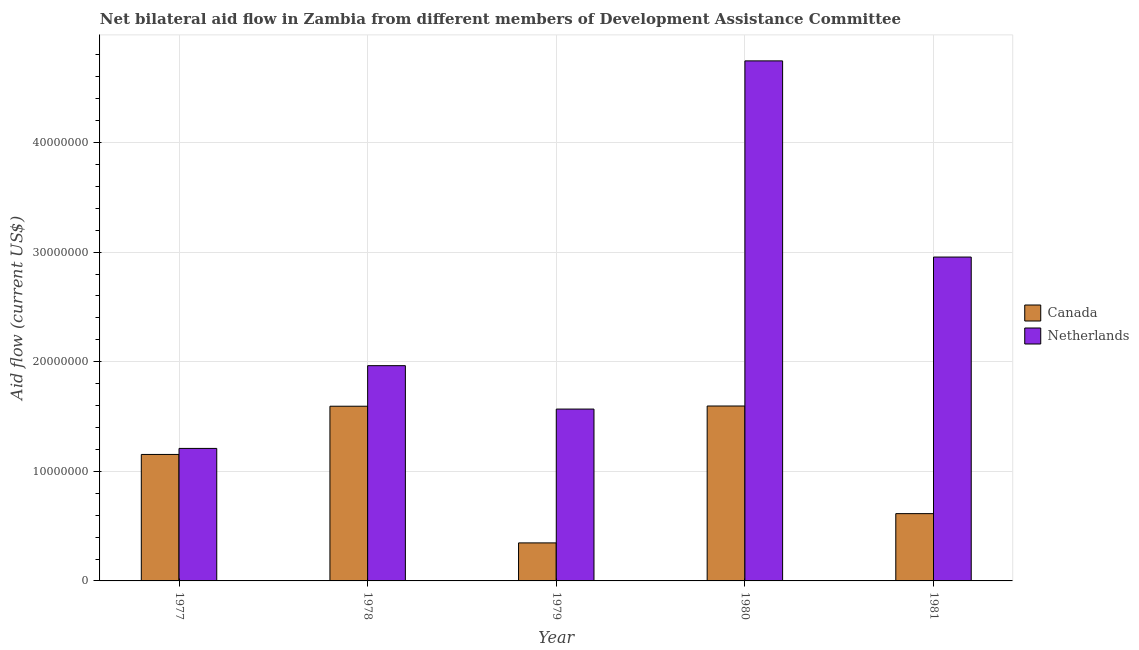How many different coloured bars are there?
Make the answer very short. 2. Are the number of bars per tick equal to the number of legend labels?
Provide a short and direct response. Yes. Are the number of bars on each tick of the X-axis equal?
Provide a succinct answer. Yes. What is the label of the 5th group of bars from the left?
Offer a very short reply. 1981. What is the amount of aid given by netherlands in 1981?
Ensure brevity in your answer.  2.96e+07. Across all years, what is the maximum amount of aid given by canada?
Give a very brief answer. 1.60e+07. Across all years, what is the minimum amount of aid given by netherlands?
Your response must be concise. 1.21e+07. In which year was the amount of aid given by canada minimum?
Provide a short and direct response. 1979. What is the total amount of aid given by canada in the graph?
Provide a short and direct response. 5.30e+07. What is the difference between the amount of aid given by canada in 1979 and that in 1980?
Give a very brief answer. -1.25e+07. What is the difference between the amount of aid given by netherlands in 1979 and the amount of aid given by canada in 1977?
Provide a short and direct response. 3.59e+06. What is the average amount of aid given by canada per year?
Your response must be concise. 1.06e+07. In how many years, is the amount of aid given by canada greater than 6000000 US$?
Your response must be concise. 4. What is the ratio of the amount of aid given by canada in 1980 to that in 1981?
Offer a terse response. 2.6. Is the amount of aid given by netherlands in 1980 less than that in 1981?
Offer a terse response. No. Is the difference between the amount of aid given by netherlands in 1978 and 1980 greater than the difference between the amount of aid given by canada in 1978 and 1980?
Your answer should be very brief. No. What is the difference between the highest and the lowest amount of aid given by canada?
Offer a terse response. 1.25e+07. What does the 1st bar from the left in 1981 represents?
Provide a succinct answer. Canada. How many bars are there?
Your answer should be very brief. 10. Are all the bars in the graph horizontal?
Provide a succinct answer. No. How many years are there in the graph?
Ensure brevity in your answer.  5. Does the graph contain any zero values?
Your answer should be compact. No. How many legend labels are there?
Offer a very short reply. 2. How are the legend labels stacked?
Your answer should be compact. Vertical. What is the title of the graph?
Make the answer very short. Net bilateral aid flow in Zambia from different members of Development Assistance Committee. Does "Lower secondary rate" appear as one of the legend labels in the graph?
Provide a succinct answer. No. What is the label or title of the X-axis?
Your response must be concise. Year. What is the Aid flow (current US$) in Canada in 1977?
Provide a succinct answer. 1.15e+07. What is the Aid flow (current US$) in Netherlands in 1977?
Keep it short and to the point. 1.21e+07. What is the Aid flow (current US$) in Canada in 1978?
Ensure brevity in your answer.  1.59e+07. What is the Aid flow (current US$) of Netherlands in 1978?
Your response must be concise. 1.96e+07. What is the Aid flow (current US$) in Canada in 1979?
Provide a succinct answer. 3.47e+06. What is the Aid flow (current US$) in Netherlands in 1979?
Offer a terse response. 1.57e+07. What is the Aid flow (current US$) in Canada in 1980?
Your answer should be very brief. 1.60e+07. What is the Aid flow (current US$) of Netherlands in 1980?
Your response must be concise. 4.74e+07. What is the Aid flow (current US$) of Canada in 1981?
Offer a terse response. 6.14e+06. What is the Aid flow (current US$) in Netherlands in 1981?
Make the answer very short. 2.96e+07. Across all years, what is the maximum Aid flow (current US$) in Canada?
Your answer should be very brief. 1.60e+07. Across all years, what is the maximum Aid flow (current US$) in Netherlands?
Your response must be concise. 4.74e+07. Across all years, what is the minimum Aid flow (current US$) in Canada?
Provide a short and direct response. 3.47e+06. Across all years, what is the minimum Aid flow (current US$) of Netherlands?
Provide a short and direct response. 1.21e+07. What is the total Aid flow (current US$) in Canada in the graph?
Provide a succinct answer. 5.30e+07. What is the total Aid flow (current US$) in Netherlands in the graph?
Keep it short and to the point. 1.24e+08. What is the difference between the Aid flow (current US$) of Canada in 1977 and that in 1978?
Your response must be concise. -4.40e+06. What is the difference between the Aid flow (current US$) of Netherlands in 1977 and that in 1978?
Provide a short and direct response. -7.55e+06. What is the difference between the Aid flow (current US$) of Canada in 1977 and that in 1979?
Your response must be concise. 8.07e+06. What is the difference between the Aid flow (current US$) in Netherlands in 1977 and that in 1979?
Keep it short and to the point. -3.59e+06. What is the difference between the Aid flow (current US$) of Canada in 1977 and that in 1980?
Keep it short and to the point. -4.42e+06. What is the difference between the Aid flow (current US$) of Netherlands in 1977 and that in 1980?
Your answer should be compact. -3.54e+07. What is the difference between the Aid flow (current US$) in Canada in 1977 and that in 1981?
Offer a very short reply. 5.40e+06. What is the difference between the Aid flow (current US$) of Netherlands in 1977 and that in 1981?
Give a very brief answer. -1.75e+07. What is the difference between the Aid flow (current US$) of Canada in 1978 and that in 1979?
Your answer should be very brief. 1.25e+07. What is the difference between the Aid flow (current US$) in Netherlands in 1978 and that in 1979?
Keep it short and to the point. 3.96e+06. What is the difference between the Aid flow (current US$) in Canada in 1978 and that in 1980?
Keep it short and to the point. -2.00e+04. What is the difference between the Aid flow (current US$) of Netherlands in 1978 and that in 1980?
Your answer should be very brief. -2.78e+07. What is the difference between the Aid flow (current US$) of Canada in 1978 and that in 1981?
Your answer should be very brief. 9.80e+06. What is the difference between the Aid flow (current US$) of Netherlands in 1978 and that in 1981?
Your response must be concise. -9.91e+06. What is the difference between the Aid flow (current US$) in Canada in 1979 and that in 1980?
Offer a terse response. -1.25e+07. What is the difference between the Aid flow (current US$) in Netherlands in 1979 and that in 1980?
Ensure brevity in your answer.  -3.18e+07. What is the difference between the Aid flow (current US$) in Canada in 1979 and that in 1981?
Keep it short and to the point. -2.67e+06. What is the difference between the Aid flow (current US$) in Netherlands in 1979 and that in 1981?
Give a very brief answer. -1.39e+07. What is the difference between the Aid flow (current US$) in Canada in 1980 and that in 1981?
Provide a succinct answer. 9.82e+06. What is the difference between the Aid flow (current US$) of Netherlands in 1980 and that in 1981?
Give a very brief answer. 1.79e+07. What is the difference between the Aid flow (current US$) in Canada in 1977 and the Aid flow (current US$) in Netherlands in 1978?
Provide a short and direct response. -8.10e+06. What is the difference between the Aid flow (current US$) in Canada in 1977 and the Aid flow (current US$) in Netherlands in 1979?
Keep it short and to the point. -4.14e+06. What is the difference between the Aid flow (current US$) in Canada in 1977 and the Aid flow (current US$) in Netherlands in 1980?
Offer a terse response. -3.59e+07. What is the difference between the Aid flow (current US$) of Canada in 1977 and the Aid flow (current US$) of Netherlands in 1981?
Offer a very short reply. -1.80e+07. What is the difference between the Aid flow (current US$) in Canada in 1978 and the Aid flow (current US$) in Netherlands in 1979?
Make the answer very short. 2.60e+05. What is the difference between the Aid flow (current US$) of Canada in 1978 and the Aid flow (current US$) of Netherlands in 1980?
Your answer should be compact. -3.15e+07. What is the difference between the Aid flow (current US$) of Canada in 1978 and the Aid flow (current US$) of Netherlands in 1981?
Offer a very short reply. -1.36e+07. What is the difference between the Aid flow (current US$) of Canada in 1979 and the Aid flow (current US$) of Netherlands in 1980?
Offer a terse response. -4.40e+07. What is the difference between the Aid flow (current US$) of Canada in 1979 and the Aid flow (current US$) of Netherlands in 1981?
Make the answer very short. -2.61e+07. What is the difference between the Aid flow (current US$) of Canada in 1980 and the Aid flow (current US$) of Netherlands in 1981?
Your response must be concise. -1.36e+07. What is the average Aid flow (current US$) of Canada per year?
Provide a short and direct response. 1.06e+07. What is the average Aid flow (current US$) of Netherlands per year?
Your response must be concise. 2.49e+07. In the year 1977, what is the difference between the Aid flow (current US$) of Canada and Aid flow (current US$) of Netherlands?
Offer a terse response. -5.50e+05. In the year 1978, what is the difference between the Aid flow (current US$) of Canada and Aid flow (current US$) of Netherlands?
Make the answer very short. -3.70e+06. In the year 1979, what is the difference between the Aid flow (current US$) in Canada and Aid flow (current US$) in Netherlands?
Your answer should be very brief. -1.22e+07. In the year 1980, what is the difference between the Aid flow (current US$) in Canada and Aid flow (current US$) in Netherlands?
Your answer should be very brief. -3.15e+07. In the year 1981, what is the difference between the Aid flow (current US$) in Canada and Aid flow (current US$) in Netherlands?
Provide a short and direct response. -2.34e+07. What is the ratio of the Aid flow (current US$) in Canada in 1977 to that in 1978?
Offer a terse response. 0.72. What is the ratio of the Aid flow (current US$) of Netherlands in 1977 to that in 1978?
Your answer should be compact. 0.62. What is the ratio of the Aid flow (current US$) in Canada in 1977 to that in 1979?
Offer a terse response. 3.33. What is the ratio of the Aid flow (current US$) in Netherlands in 1977 to that in 1979?
Your answer should be compact. 0.77. What is the ratio of the Aid flow (current US$) of Canada in 1977 to that in 1980?
Your response must be concise. 0.72. What is the ratio of the Aid flow (current US$) in Netherlands in 1977 to that in 1980?
Provide a short and direct response. 0.25. What is the ratio of the Aid flow (current US$) of Canada in 1977 to that in 1981?
Keep it short and to the point. 1.88. What is the ratio of the Aid flow (current US$) in Netherlands in 1977 to that in 1981?
Provide a short and direct response. 0.41. What is the ratio of the Aid flow (current US$) of Canada in 1978 to that in 1979?
Offer a terse response. 4.59. What is the ratio of the Aid flow (current US$) of Netherlands in 1978 to that in 1979?
Keep it short and to the point. 1.25. What is the ratio of the Aid flow (current US$) in Canada in 1978 to that in 1980?
Make the answer very short. 1. What is the ratio of the Aid flow (current US$) of Netherlands in 1978 to that in 1980?
Ensure brevity in your answer.  0.41. What is the ratio of the Aid flow (current US$) in Canada in 1978 to that in 1981?
Offer a terse response. 2.6. What is the ratio of the Aid flow (current US$) of Netherlands in 1978 to that in 1981?
Give a very brief answer. 0.66. What is the ratio of the Aid flow (current US$) of Canada in 1979 to that in 1980?
Offer a terse response. 0.22. What is the ratio of the Aid flow (current US$) in Netherlands in 1979 to that in 1980?
Your response must be concise. 0.33. What is the ratio of the Aid flow (current US$) of Canada in 1979 to that in 1981?
Your answer should be very brief. 0.57. What is the ratio of the Aid flow (current US$) in Netherlands in 1979 to that in 1981?
Offer a very short reply. 0.53. What is the ratio of the Aid flow (current US$) in Canada in 1980 to that in 1981?
Offer a terse response. 2.6. What is the ratio of the Aid flow (current US$) of Netherlands in 1980 to that in 1981?
Offer a very short reply. 1.61. What is the difference between the highest and the second highest Aid flow (current US$) in Canada?
Give a very brief answer. 2.00e+04. What is the difference between the highest and the second highest Aid flow (current US$) in Netherlands?
Provide a succinct answer. 1.79e+07. What is the difference between the highest and the lowest Aid flow (current US$) of Canada?
Your response must be concise. 1.25e+07. What is the difference between the highest and the lowest Aid flow (current US$) in Netherlands?
Provide a short and direct response. 3.54e+07. 